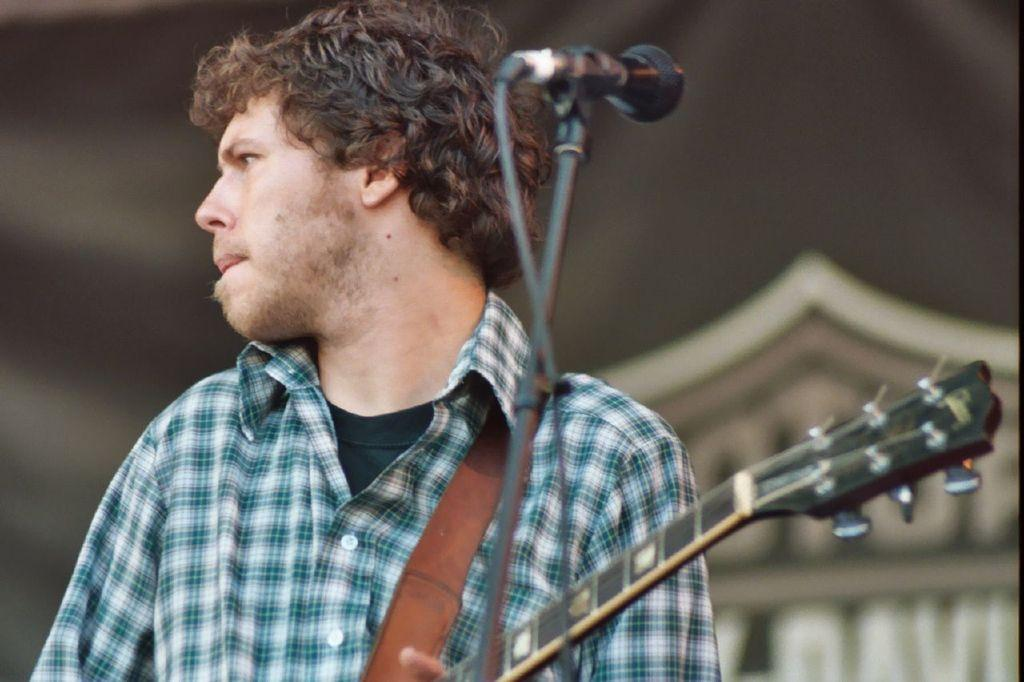What is the main subject of the image? The main subject of the image is a man. What is the man wearing in the image? The man is wearing a checkered shirt in the image. What is the man holding in the image? The man is holding a music instrument in the image. What equipment is in front of the man in the image? There is a microphone with a stand in front of the man in the image. How is the background of the man depicted in the image? The background of the man is blurred in the image. What type of bone can be seen in the man's hand in the image? There is no bone visible in the man's hand in the image; he is holding a music instrument. What order is the man following in the image? There is no specific order being followed in the image; it is a still photograph. 